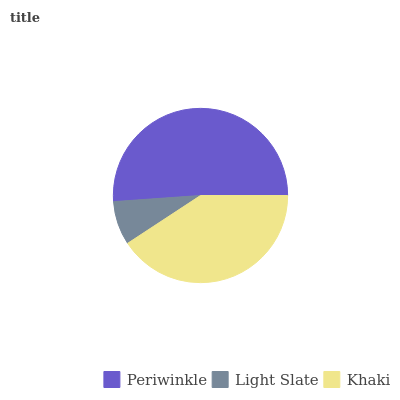Is Light Slate the minimum?
Answer yes or no. Yes. Is Periwinkle the maximum?
Answer yes or no. Yes. Is Khaki the minimum?
Answer yes or no. No. Is Khaki the maximum?
Answer yes or no. No. Is Khaki greater than Light Slate?
Answer yes or no. Yes. Is Light Slate less than Khaki?
Answer yes or no. Yes. Is Light Slate greater than Khaki?
Answer yes or no. No. Is Khaki less than Light Slate?
Answer yes or no. No. Is Khaki the high median?
Answer yes or no. Yes. Is Khaki the low median?
Answer yes or no. Yes. Is Periwinkle the high median?
Answer yes or no. No. Is Periwinkle the low median?
Answer yes or no. No. 